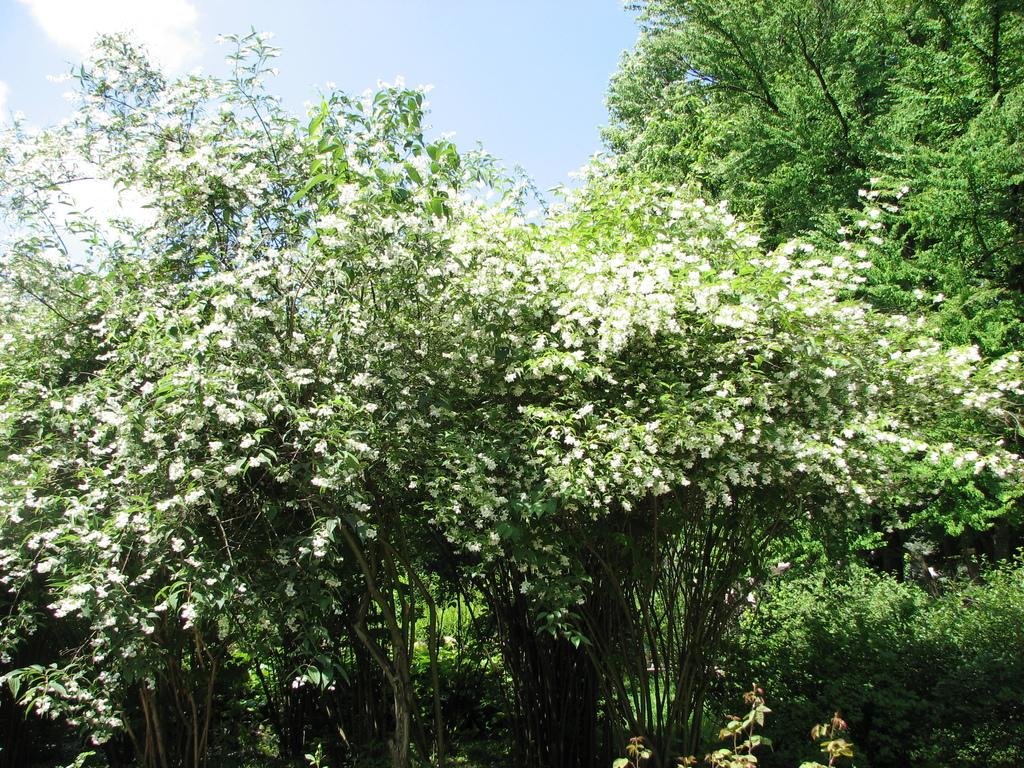What type of vegetation can be seen in the image? There are trees in the image. What is the condition of the sky in the image? The sky is cloudy in the image. What type of school can be seen in the image? There is no school present in the image; it features trees and a cloudy sky. How does the wren maintain its balance in the image? There is no wren present in the image; it only features trees and a cloudy sky. 